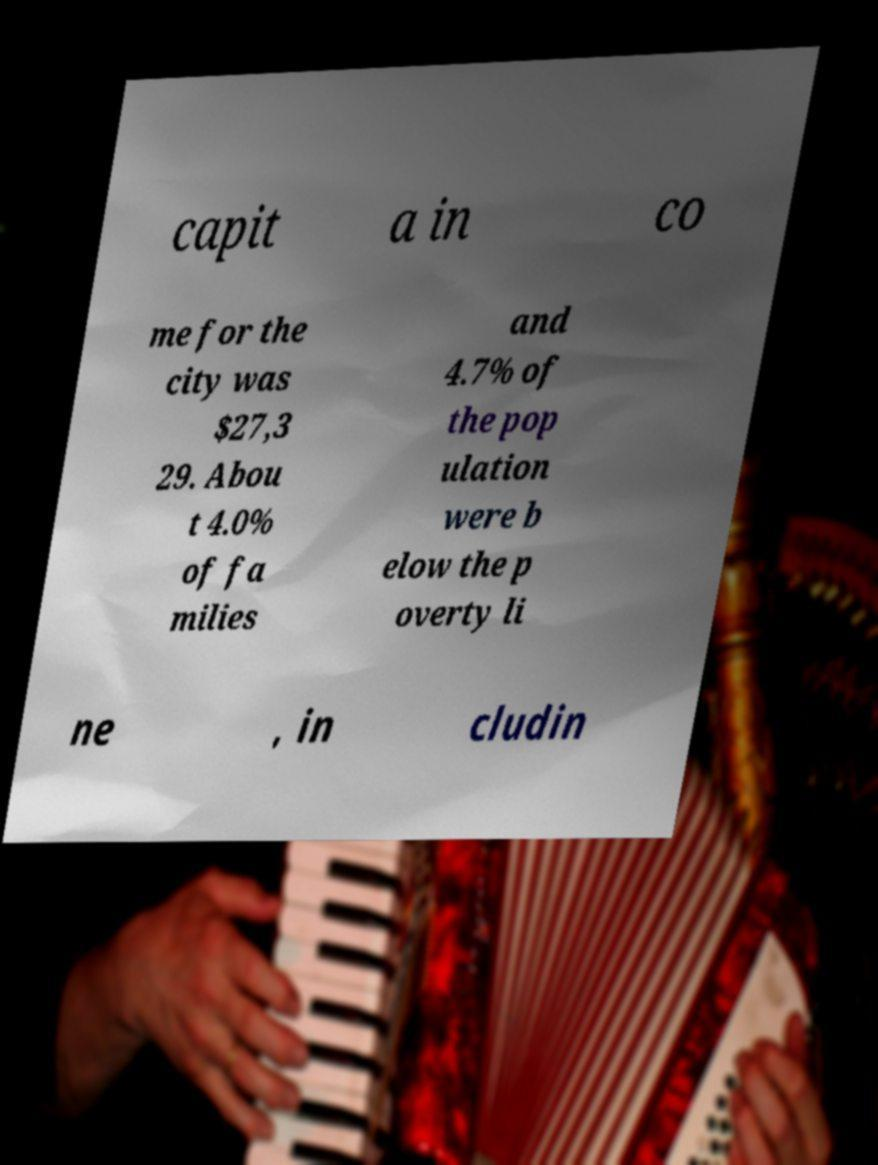There's text embedded in this image that I need extracted. Can you transcribe it verbatim? capit a in co me for the city was $27,3 29. Abou t 4.0% of fa milies and 4.7% of the pop ulation were b elow the p overty li ne , in cludin 